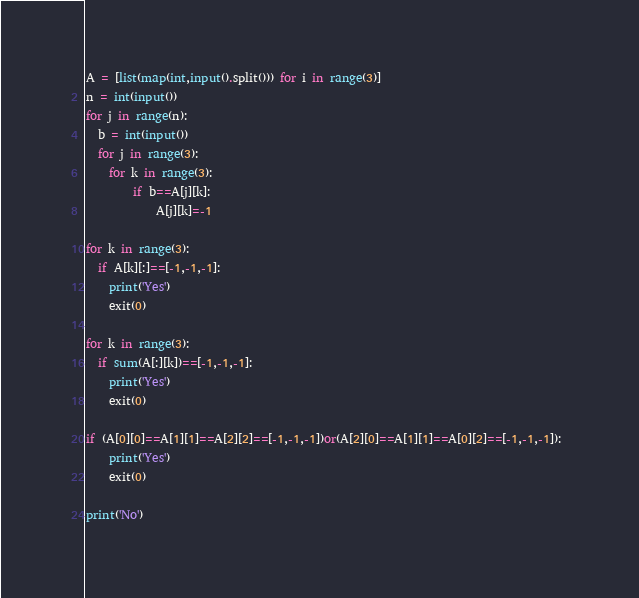Convert code to text. <code><loc_0><loc_0><loc_500><loc_500><_Python_>A = [list(map(int,input().split())) for i in range(3)]
n = int(input())
for j in range(n):
  b = int(input())
  for j in range(3):
    for k in range(3): 
    	if b==A[j][k]:
      		A[j][k]=-1

for k in range(3):
  if A[k][:]==[-1,-1,-1]:
    print('Yes')
    exit(0)
 
for k in range(3):
  if sum(A[:][k])==[-1,-1,-1]:
    print('Yes')
    exit(0)
 
if (A[0][0]==A[1][1]==A[2][2]==[-1,-1,-1])or(A[2][0]==A[1][1]==A[0][2]==[-1,-1,-1]): 
    print('Yes')
    exit(0)
    
print('No')</code> 